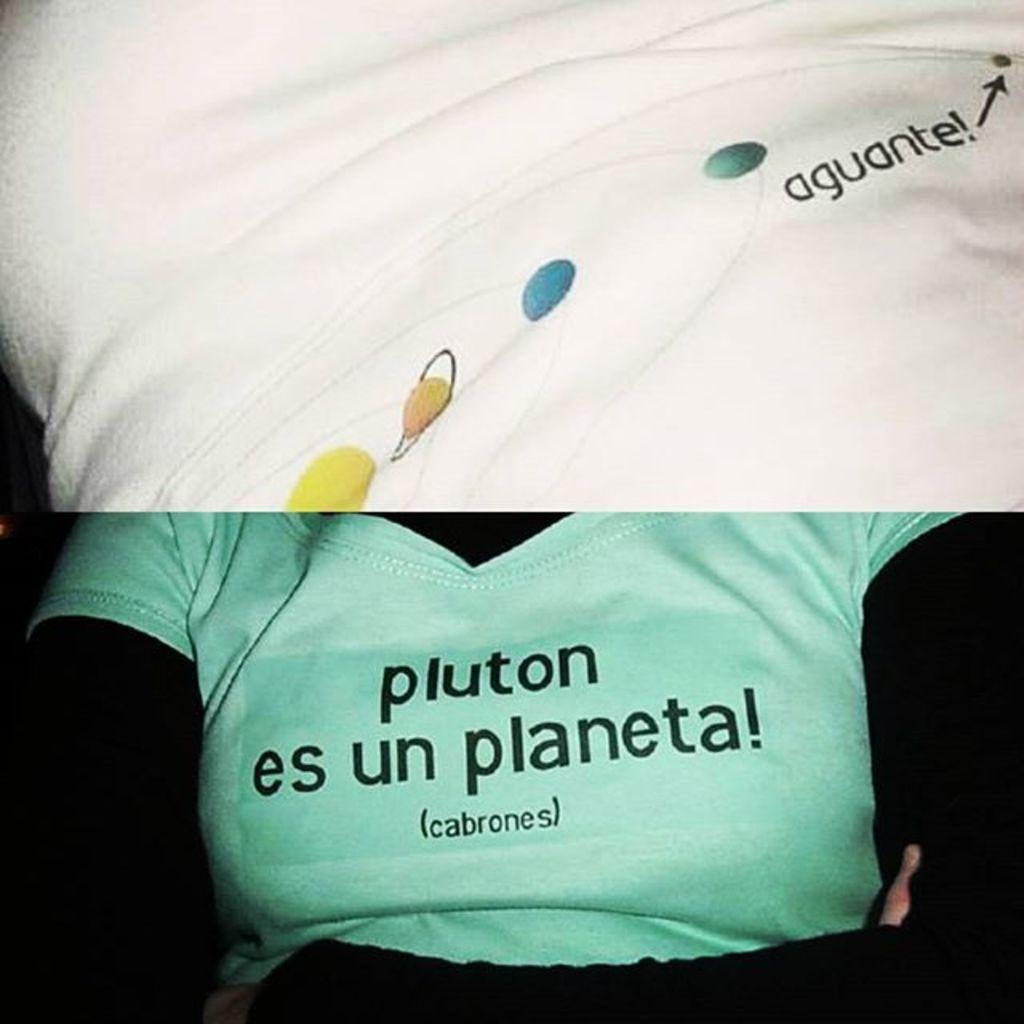In one or two sentences, can you explain what this image depicts? This is a collage image. Here I can see two pictures. In the top picture I can see a white colored cloth on which I can see some text. In the bottom picture I can see a person wearing a t-shirt. On the t-shirt I can see some text. 